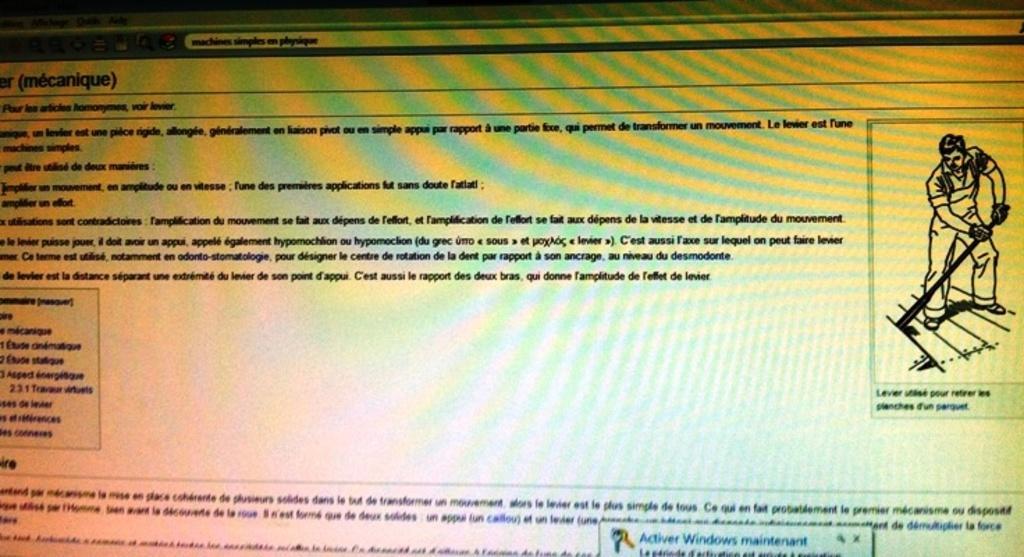Can you describe this image briefly? This picture consists of a text and image of person and on the text I can see colorful designs. 